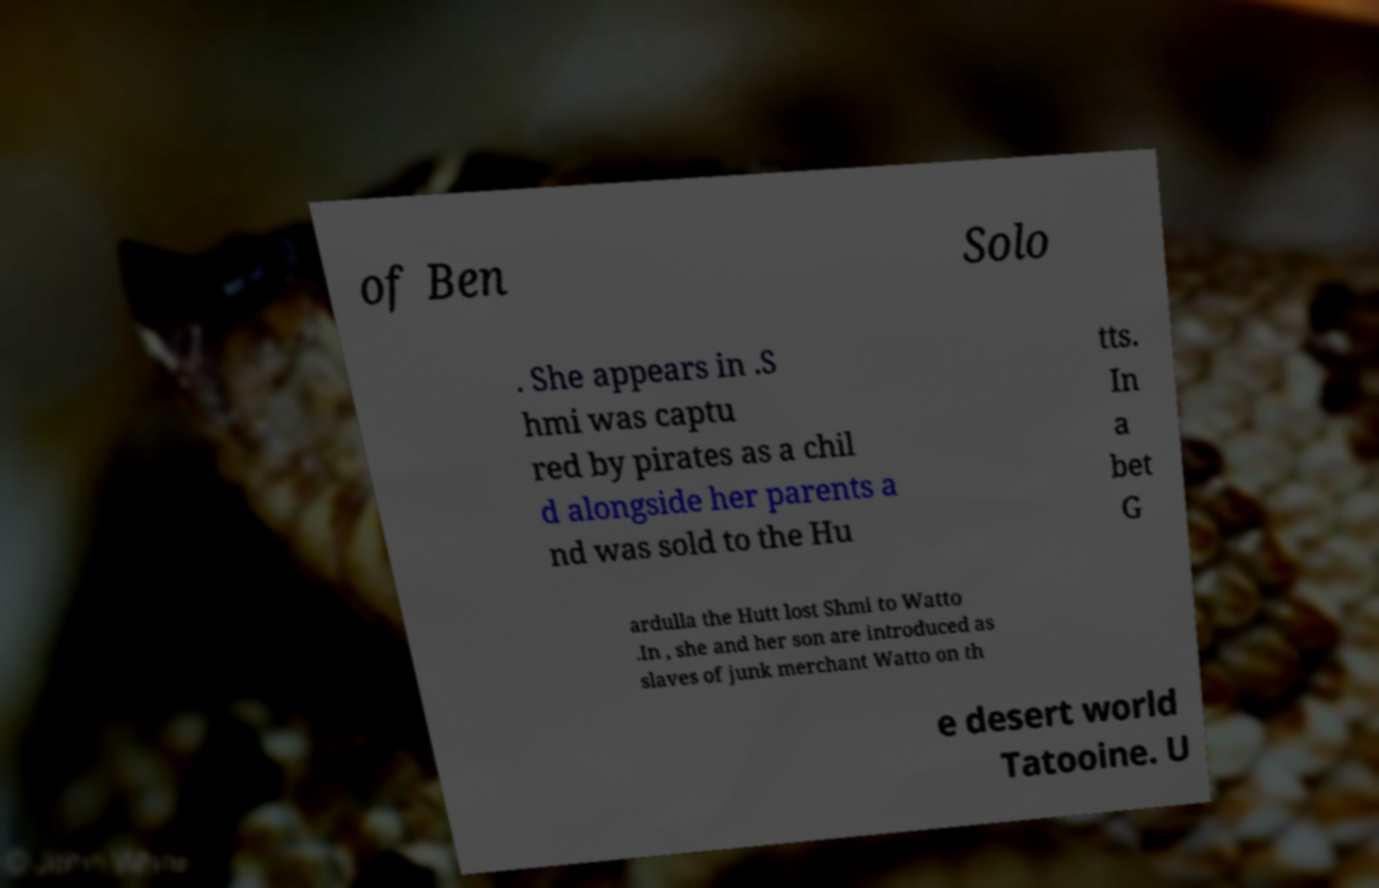Could you extract and type out the text from this image? of Ben Solo . She appears in .S hmi was captu red by pirates as a chil d alongside her parents a nd was sold to the Hu tts. In a bet G ardulla the Hutt lost Shmi to Watto .In , she and her son are introduced as slaves of junk merchant Watto on th e desert world Tatooine. U 